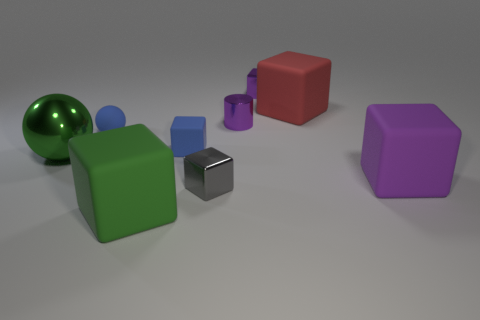Subtract all tiny rubber cubes. How many cubes are left? 5 Subtract all yellow spheres. How many purple cubes are left? 2 Subtract all purple blocks. How many blocks are left? 4 Subtract all yellow blocks. Subtract all red balls. How many blocks are left? 6 Subtract all balls. How many objects are left? 7 Add 7 gray matte objects. How many gray matte objects exist? 7 Subtract 0 cyan blocks. How many objects are left? 9 Subtract all brown rubber objects. Subtract all big green rubber cubes. How many objects are left? 8 Add 8 blue balls. How many blue balls are left? 9 